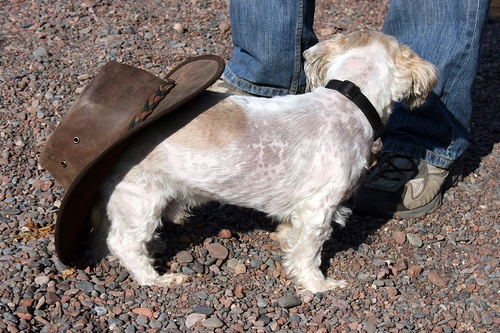Describe the objects in this image and their specific colors. I can see dog in gray, lightgray, darkgray, and black tones and people in gray, black, and blue tones in this image. 